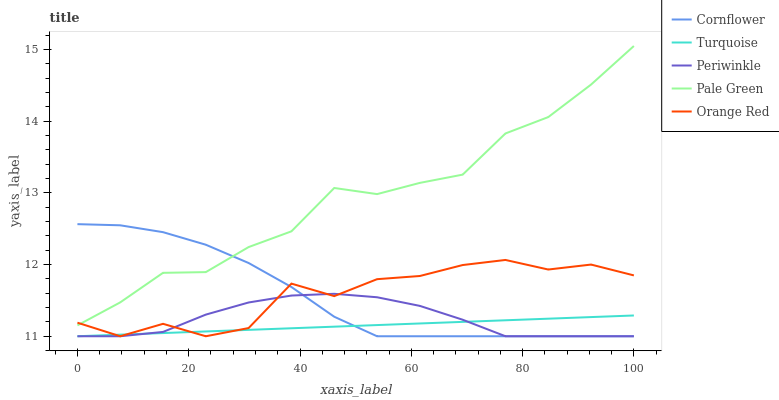Does Turquoise have the minimum area under the curve?
Answer yes or no. Yes. Does Pale Green have the maximum area under the curve?
Answer yes or no. Yes. Does Pale Green have the minimum area under the curve?
Answer yes or no. No. Does Turquoise have the maximum area under the curve?
Answer yes or no. No. Is Turquoise the smoothest?
Answer yes or no. Yes. Is Orange Red the roughest?
Answer yes or no. Yes. Is Pale Green the smoothest?
Answer yes or no. No. Is Pale Green the roughest?
Answer yes or no. No. Does Cornflower have the lowest value?
Answer yes or no. Yes. Does Pale Green have the lowest value?
Answer yes or no. No. Does Pale Green have the highest value?
Answer yes or no. Yes. Does Turquoise have the highest value?
Answer yes or no. No. Is Turquoise less than Pale Green?
Answer yes or no. Yes. Is Pale Green greater than Periwinkle?
Answer yes or no. Yes. Does Orange Red intersect Pale Green?
Answer yes or no. Yes. Is Orange Red less than Pale Green?
Answer yes or no. No. Is Orange Red greater than Pale Green?
Answer yes or no. No. Does Turquoise intersect Pale Green?
Answer yes or no. No. 